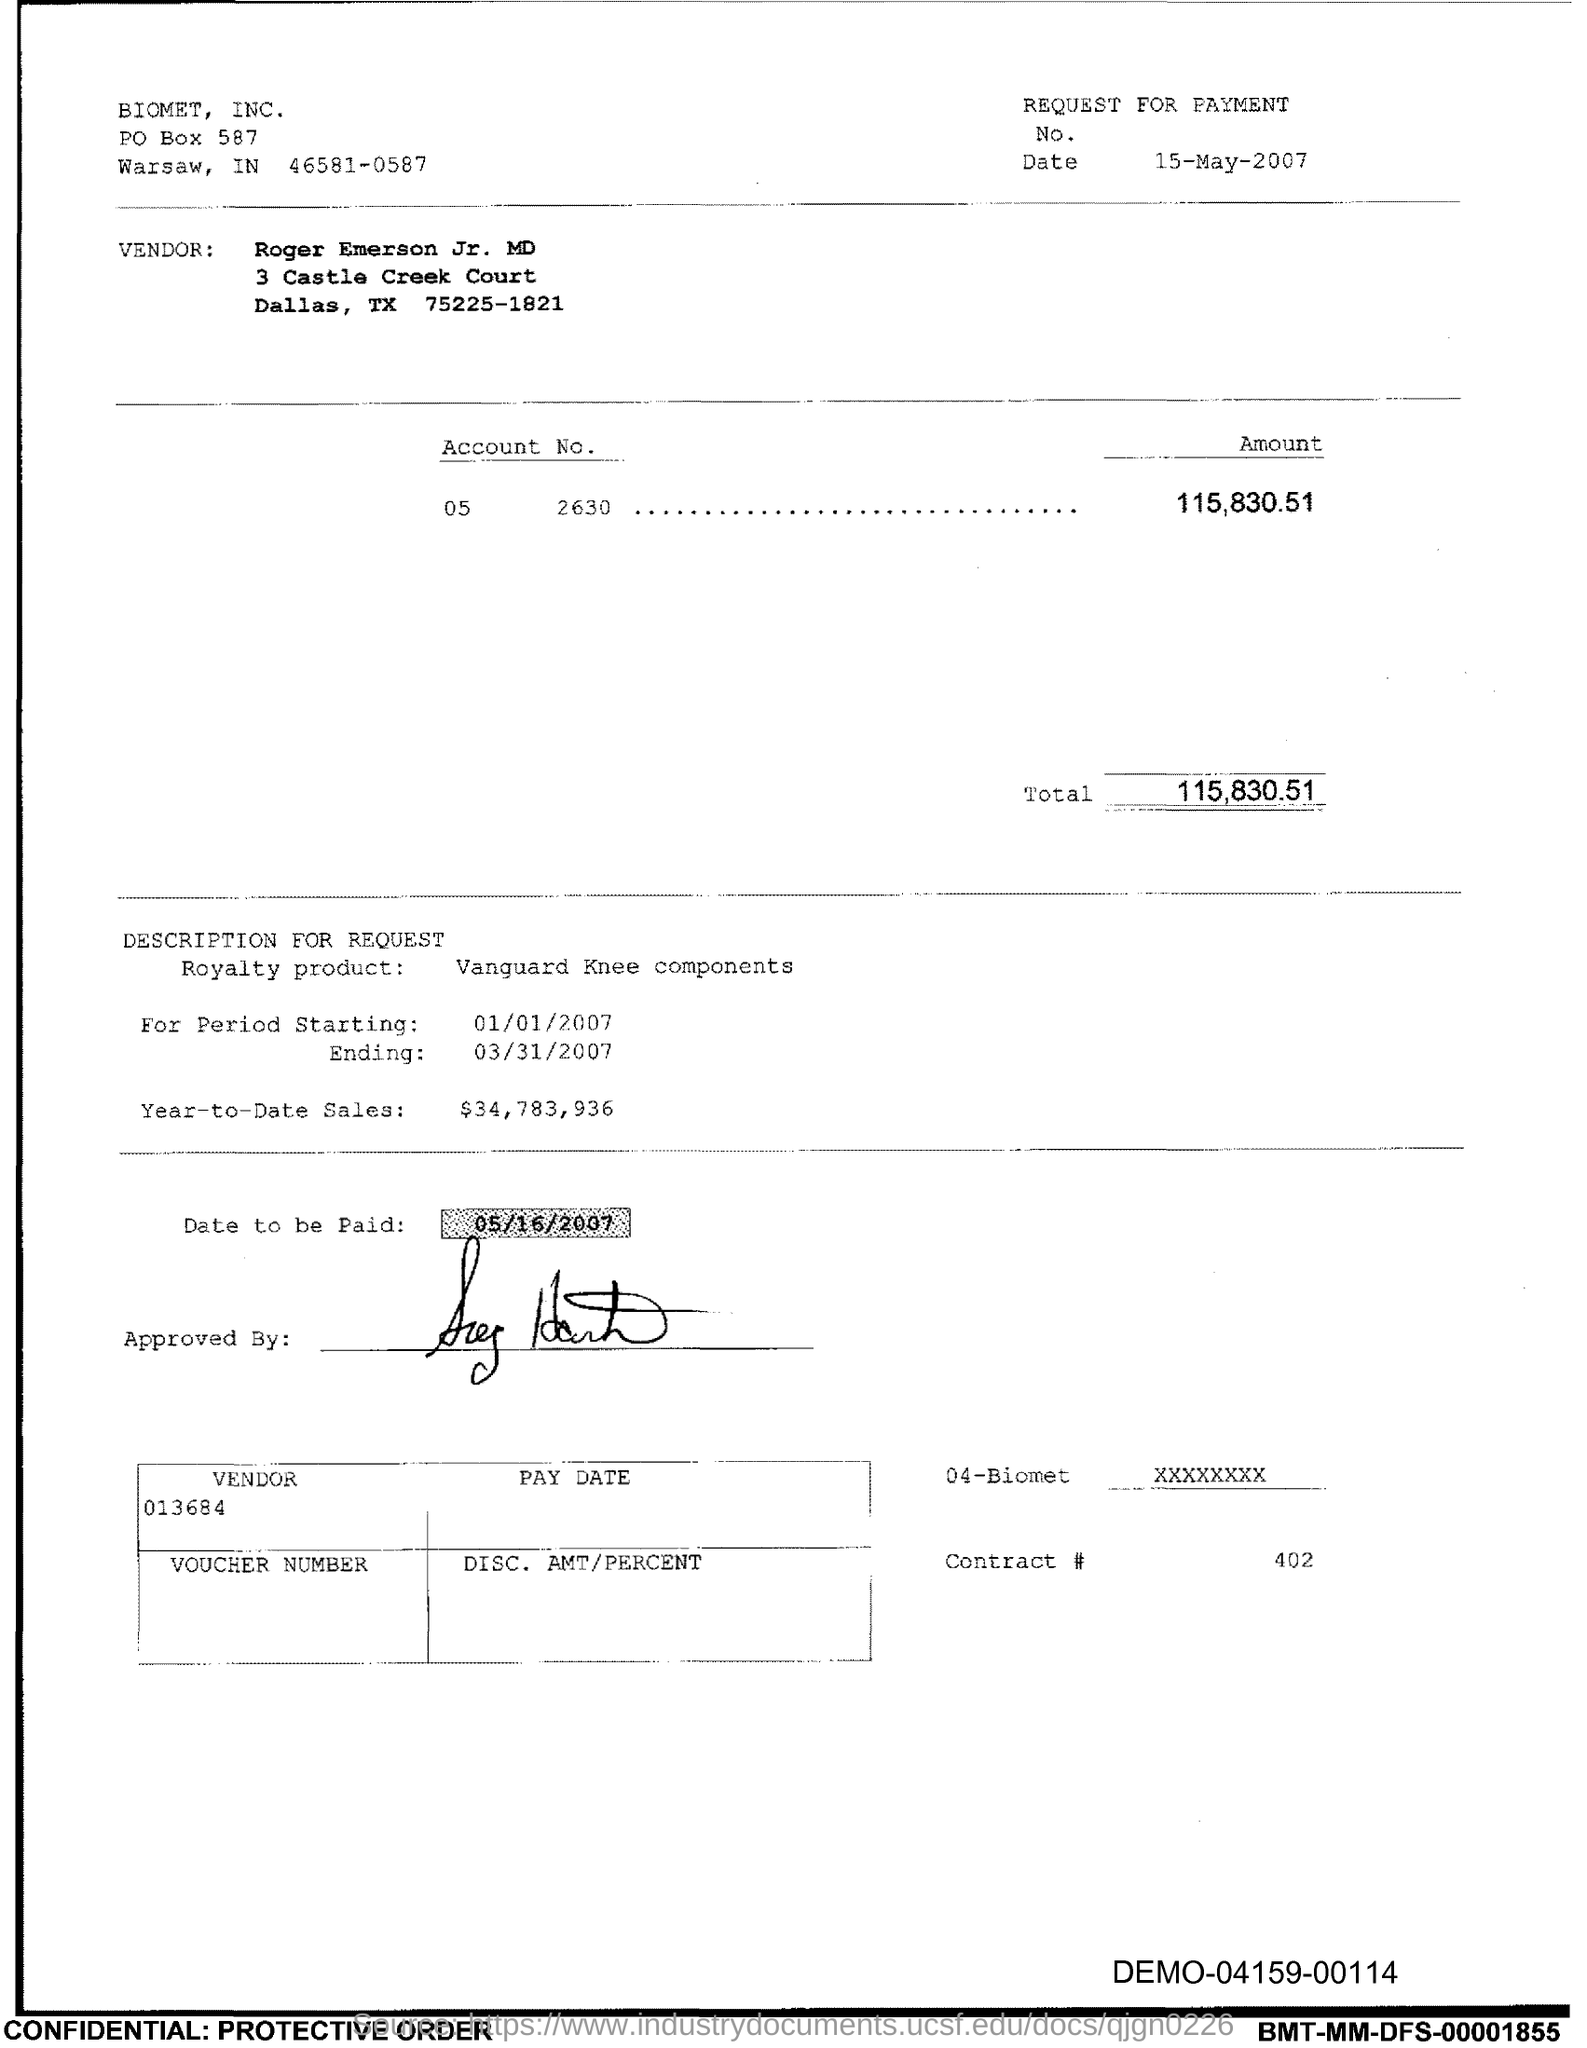Which company is mentioned in the header of the document?
Ensure brevity in your answer.  BIOMET, INC. Who is the Vendor mentioned in the document?
Offer a very short reply. Roger Emerson Jr. MD. What is the Account No. given in the document?
Your response must be concise. 05 2630. What is the total amount to be paid given in the document?
Offer a terse response. 115,830.51. What is the royalty product as per the document?
Provide a short and direct response. Vanguard Knee Components. What is the date to be paid mentioned in the document?
Your answer should be compact. 05/16/2007. What is the Year-to-Date Sales of the royalty product?
Offer a terse response. $34,783,936. What is the contract # given in the document?
Ensure brevity in your answer.  402. 